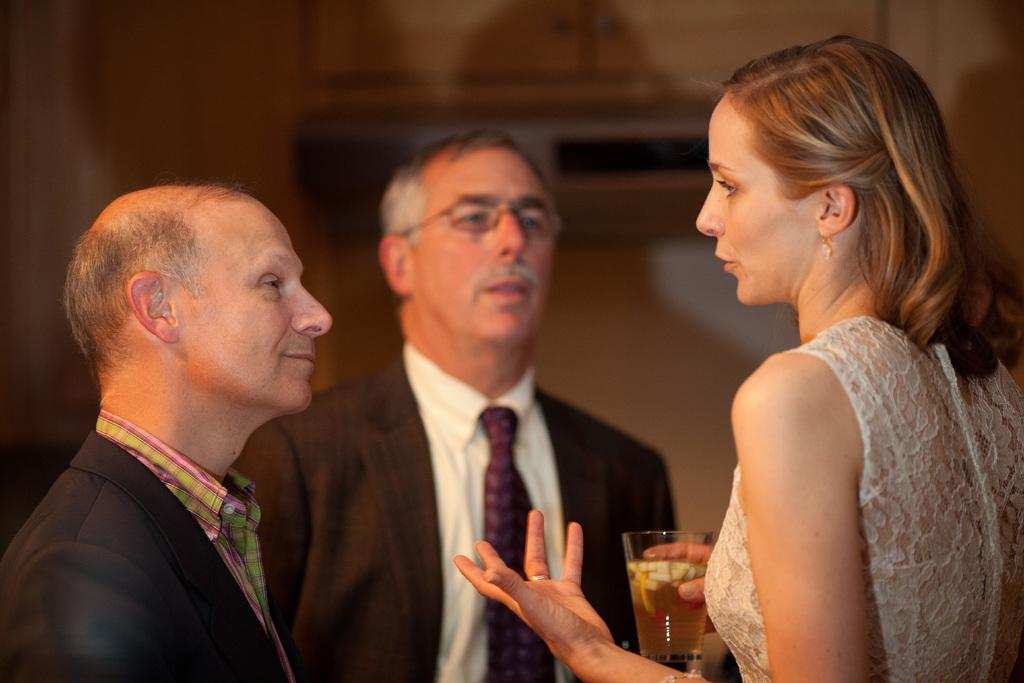How many people are present in the image? There are three people in the image: two men and a woman. What is the woman holding in the image? The woman is holding a glass in the image. What can be seen in the background of the image? There is a wall visible in the background of the image. How many frogs are sitting on the pie in the image? There are no frogs or pies present in the image. What type of knowledge is the woman sharing with the men in the image? The image does not provide any information about the conversation or knowledge being shared among the individuals. 